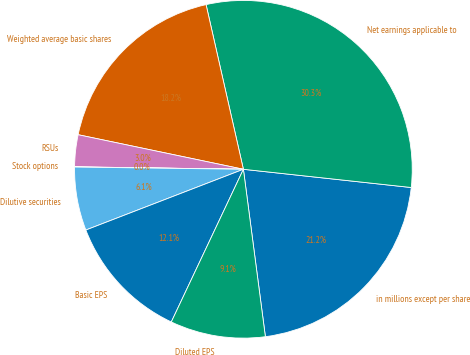<chart> <loc_0><loc_0><loc_500><loc_500><pie_chart><fcel>in millions except per share<fcel>Net earnings applicable to<fcel>Weighted average basic shares<fcel>RSUs<fcel>Stock options<fcel>Dilutive securities<fcel>Basic EPS<fcel>Diluted EPS<nl><fcel>21.2%<fcel>30.27%<fcel>18.17%<fcel>3.05%<fcel>0.02%<fcel>6.07%<fcel>12.12%<fcel>9.1%<nl></chart> 